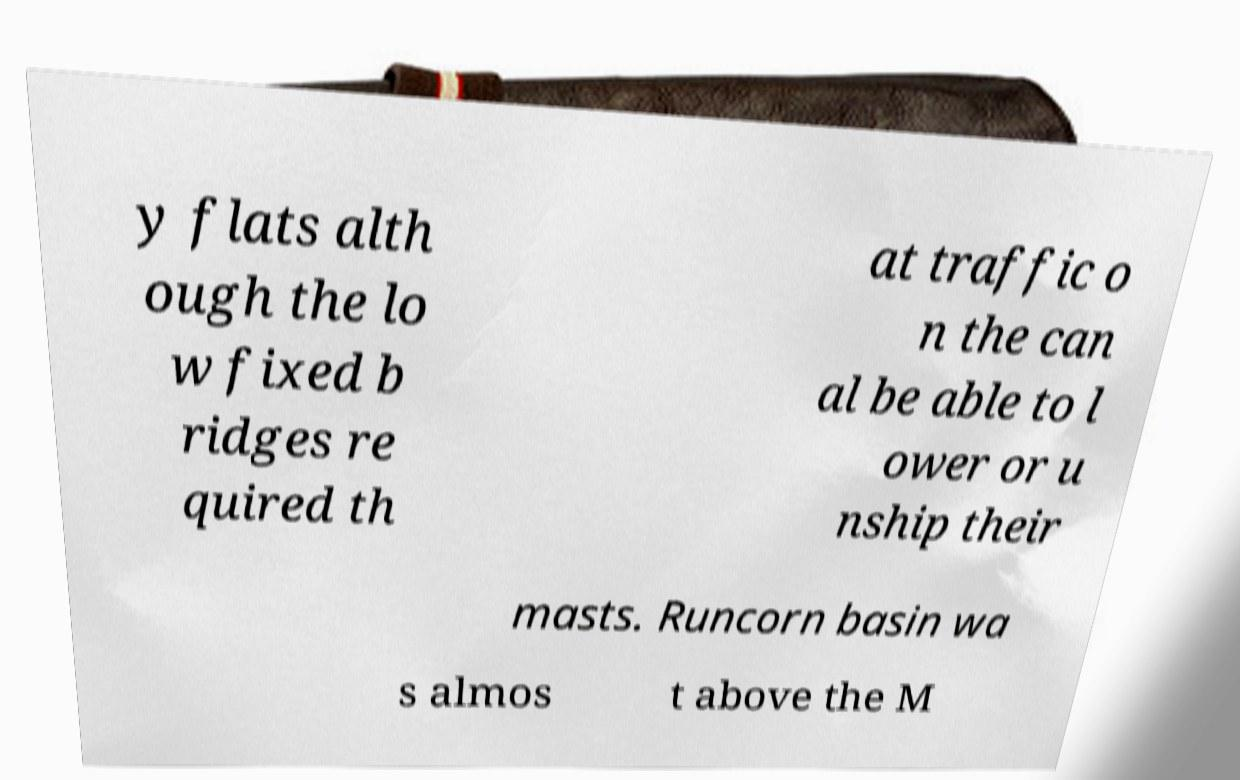I need the written content from this picture converted into text. Can you do that? y flats alth ough the lo w fixed b ridges re quired th at traffic o n the can al be able to l ower or u nship their masts. Runcorn basin wa s almos t above the M 